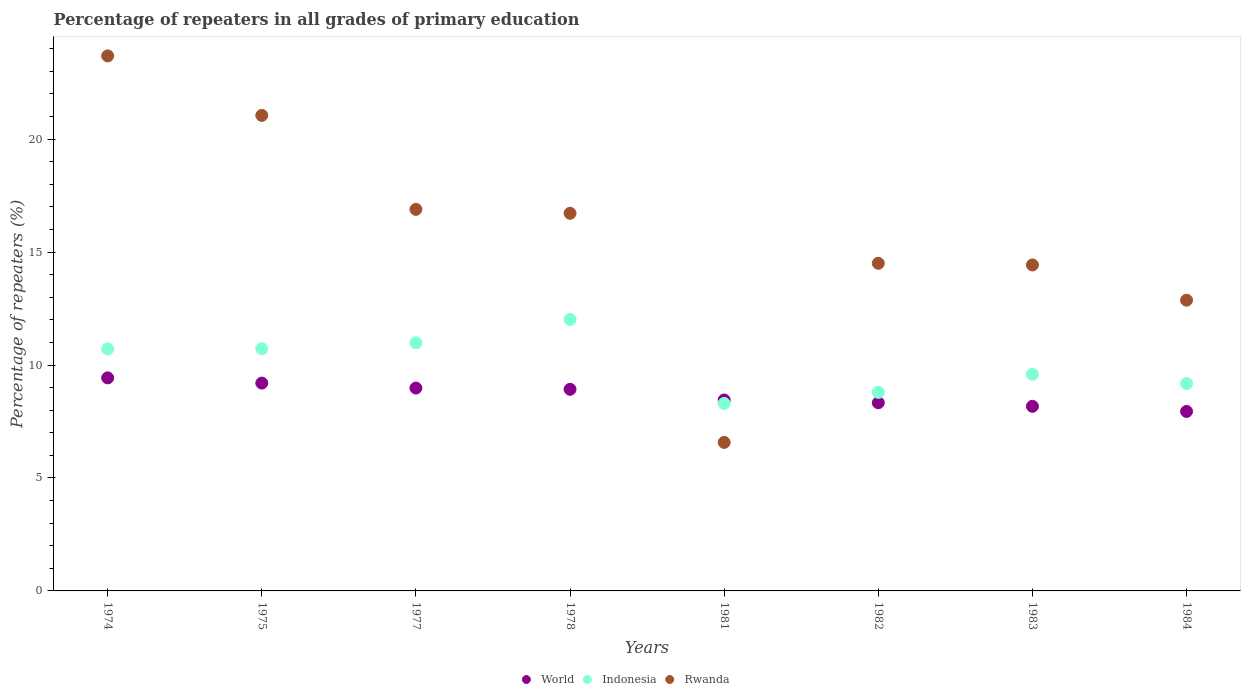What is the percentage of repeaters in Rwanda in 1978?
Your answer should be very brief. 16.72. Across all years, what is the maximum percentage of repeaters in Indonesia?
Offer a very short reply. 12.02. Across all years, what is the minimum percentage of repeaters in World?
Your answer should be very brief. 7.95. In which year was the percentage of repeaters in Indonesia maximum?
Your answer should be compact. 1978. In which year was the percentage of repeaters in World minimum?
Offer a terse response. 1984. What is the total percentage of repeaters in World in the graph?
Offer a terse response. 69.44. What is the difference between the percentage of repeaters in World in 1978 and that in 1982?
Your answer should be very brief. 0.6. What is the difference between the percentage of repeaters in Indonesia in 1983 and the percentage of repeaters in Rwanda in 1982?
Offer a very short reply. -4.91. What is the average percentage of repeaters in Indonesia per year?
Offer a terse response. 10.04. In the year 1982, what is the difference between the percentage of repeaters in Rwanda and percentage of repeaters in World?
Ensure brevity in your answer.  6.17. What is the ratio of the percentage of repeaters in World in 1982 to that in 1984?
Offer a very short reply. 1.05. Is the difference between the percentage of repeaters in Rwanda in 1981 and 1983 greater than the difference between the percentage of repeaters in World in 1981 and 1983?
Your response must be concise. No. What is the difference between the highest and the second highest percentage of repeaters in Indonesia?
Keep it short and to the point. 1.03. What is the difference between the highest and the lowest percentage of repeaters in Indonesia?
Offer a terse response. 3.72. In how many years, is the percentage of repeaters in Rwanda greater than the average percentage of repeaters in Rwanda taken over all years?
Offer a terse response. 4. Is it the case that in every year, the sum of the percentage of repeaters in Indonesia and percentage of repeaters in World  is greater than the percentage of repeaters in Rwanda?
Provide a short and direct response. No. Is the percentage of repeaters in Indonesia strictly less than the percentage of repeaters in Rwanda over the years?
Offer a terse response. No. How many years are there in the graph?
Make the answer very short. 8. What is the difference between two consecutive major ticks on the Y-axis?
Offer a very short reply. 5. Does the graph contain any zero values?
Your answer should be very brief. No. How are the legend labels stacked?
Your answer should be compact. Horizontal. What is the title of the graph?
Offer a terse response. Percentage of repeaters in all grades of primary education. Does "Mauritius" appear as one of the legend labels in the graph?
Make the answer very short. No. What is the label or title of the X-axis?
Give a very brief answer. Years. What is the label or title of the Y-axis?
Your answer should be compact. Percentage of repeaters (%). What is the Percentage of repeaters (%) of World in 1974?
Provide a succinct answer. 9.43. What is the Percentage of repeaters (%) of Indonesia in 1974?
Ensure brevity in your answer.  10.71. What is the Percentage of repeaters (%) in Rwanda in 1974?
Your answer should be very brief. 23.69. What is the Percentage of repeaters (%) of World in 1975?
Your answer should be compact. 9.2. What is the Percentage of repeaters (%) of Indonesia in 1975?
Make the answer very short. 10.72. What is the Percentage of repeaters (%) of Rwanda in 1975?
Ensure brevity in your answer.  21.05. What is the Percentage of repeaters (%) of World in 1977?
Provide a short and direct response. 8.98. What is the Percentage of repeaters (%) of Indonesia in 1977?
Provide a succinct answer. 10.98. What is the Percentage of repeaters (%) of Rwanda in 1977?
Your answer should be compact. 16.89. What is the Percentage of repeaters (%) of World in 1978?
Your response must be concise. 8.93. What is the Percentage of repeaters (%) of Indonesia in 1978?
Provide a succinct answer. 12.02. What is the Percentage of repeaters (%) of Rwanda in 1978?
Provide a succinct answer. 16.72. What is the Percentage of repeaters (%) in World in 1981?
Your answer should be compact. 8.45. What is the Percentage of repeaters (%) of Indonesia in 1981?
Offer a terse response. 8.3. What is the Percentage of repeaters (%) in Rwanda in 1981?
Offer a terse response. 6.58. What is the Percentage of repeaters (%) in World in 1982?
Provide a succinct answer. 8.33. What is the Percentage of repeaters (%) in Indonesia in 1982?
Ensure brevity in your answer.  8.79. What is the Percentage of repeaters (%) of Rwanda in 1982?
Keep it short and to the point. 14.5. What is the Percentage of repeaters (%) of World in 1983?
Provide a short and direct response. 8.17. What is the Percentage of repeaters (%) in Indonesia in 1983?
Offer a terse response. 9.59. What is the Percentage of repeaters (%) in Rwanda in 1983?
Keep it short and to the point. 14.43. What is the Percentage of repeaters (%) in World in 1984?
Make the answer very short. 7.95. What is the Percentage of repeaters (%) in Indonesia in 1984?
Offer a terse response. 9.18. What is the Percentage of repeaters (%) of Rwanda in 1984?
Offer a terse response. 12.87. Across all years, what is the maximum Percentage of repeaters (%) in World?
Your response must be concise. 9.43. Across all years, what is the maximum Percentage of repeaters (%) in Indonesia?
Ensure brevity in your answer.  12.02. Across all years, what is the maximum Percentage of repeaters (%) in Rwanda?
Keep it short and to the point. 23.69. Across all years, what is the minimum Percentage of repeaters (%) in World?
Make the answer very short. 7.95. Across all years, what is the minimum Percentage of repeaters (%) in Indonesia?
Keep it short and to the point. 8.3. Across all years, what is the minimum Percentage of repeaters (%) of Rwanda?
Keep it short and to the point. 6.58. What is the total Percentage of repeaters (%) of World in the graph?
Keep it short and to the point. 69.44. What is the total Percentage of repeaters (%) of Indonesia in the graph?
Provide a succinct answer. 80.3. What is the total Percentage of repeaters (%) of Rwanda in the graph?
Make the answer very short. 126.73. What is the difference between the Percentage of repeaters (%) in World in 1974 and that in 1975?
Ensure brevity in your answer.  0.23. What is the difference between the Percentage of repeaters (%) in Indonesia in 1974 and that in 1975?
Your response must be concise. -0.01. What is the difference between the Percentage of repeaters (%) of Rwanda in 1974 and that in 1975?
Your response must be concise. 2.63. What is the difference between the Percentage of repeaters (%) of World in 1974 and that in 1977?
Make the answer very short. 0.45. What is the difference between the Percentage of repeaters (%) of Indonesia in 1974 and that in 1977?
Ensure brevity in your answer.  -0.27. What is the difference between the Percentage of repeaters (%) of Rwanda in 1974 and that in 1977?
Give a very brief answer. 6.79. What is the difference between the Percentage of repeaters (%) of World in 1974 and that in 1978?
Your answer should be very brief. 0.51. What is the difference between the Percentage of repeaters (%) in Indonesia in 1974 and that in 1978?
Your answer should be compact. -1.3. What is the difference between the Percentage of repeaters (%) in Rwanda in 1974 and that in 1978?
Offer a terse response. 6.97. What is the difference between the Percentage of repeaters (%) of World in 1974 and that in 1981?
Your answer should be compact. 0.98. What is the difference between the Percentage of repeaters (%) of Indonesia in 1974 and that in 1981?
Make the answer very short. 2.41. What is the difference between the Percentage of repeaters (%) of Rwanda in 1974 and that in 1981?
Your response must be concise. 17.11. What is the difference between the Percentage of repeaters (%) of World in 1974 and that in 1982?
Make the answer very short. 1.1. What is the difference between the Percentage of repeaters (%) of Indonesia in 1974 and that in 1982?
Give a very brief answer. 1.92. What is the difference between the Percentage of repeaters (%) of Rwanda in 1974 and that in 1982?
Your answer should be compact. 9.18. What is the difference between the Percentage of repeaters (%) in World in 1974 and that in 1983?
Ensure brevity in your answer.  1.26. What is the difference between the Percentage of repeaters (%) in Indonesia in 1974 and that in 1983?
Keep it short and to the point. 1.12. What is the difference between the Percentage of repeaters (%) in Rwanda in 1974 and that in 1983?
Make the answer very short. 9.25. What is the difference between the Percentage of repeaters (%) of World in 1974 and that in 1984?
Provide a short and direct response. 1.49. What is the difference between the Percentage of repeaters (%) of Indonesia in 1974 and that in 1984?
Your response must be concise. 1.53. What is the difference between the Percentage of repeaters (%) of Rwanda in 1974 and that in 1984?
Your answer should be compact. 10.81. What is the difference between the Percentage of repeaters (%) in World in 1975 and that in 1977?
Your answer should be very brief. 0.22. What is the difference between the Percentage of repeaters (%) of Indonesia in 1975 and that in 1977?
Your answer should be compact. -0.26. What is the difference between the Percentage of repeaters (%) of Rwanda in 1975 and that in 1977?
Ensure brevity in your answer.  4.16. What is the difference between the Percentage of repeaters (%) of World in 1975 and that in 1978?
Your answer should be very brief. 0.28. What is the difference between the Percentage of repeaters (%) in Indonesia in 1975 and that in 1978?
Provide a succinct answer. -1.29. What is the difference between the Percentage of repeaters (%) of Rwanda in 1975 and that in 1978?
Ensure brevity in your answer.  4.33. What is the difference between the Percentage of repeaters (%) in World in 1975 and that in 1981?
Make the answer very short. 0.75. What is the difference between the Percentage of repeaters (%) in Indonesia in 1975 and that in 1981?
Keep it short and to the point. 2.42. What is the difference between the Percentage of repeaters (%) of Rwanda in 1975 and that in 1981?
Your answer should be very brief. 14.48. What is the difference between the Percentage of repeaters (%) in World in 1975 and that in 1982?
Your response must be concise. 0.87. What is the difference between the Percentage of repeaters (%) of Indonesia in 1975 and that in 1982?
Your answer should be compact. 1.93. What is the difference between the Percentage of repeaters (%) of Rwanda in 1975 and that in 1982?
Your response must be concise. 6.55. What is the difference between the Percentage of repeaters (%) in World in 1975 and that in 1983?
Provide a short and direct response. 1.03. What is the difference between the Percentage of repeaters (%) in Indonesia in 1975 and that in 1983?
Your response must be concise. 1.13. What is the difference between the Percentage of repeaters (%) in Rwanda in 1975 and that in 1983?
Offer a terse response. 6.62. What is the difference between the Percentage of repeaters (%) of World in 1975 and that in 1984?
Give a very brief answer. 1.26. What is the difference between the Percentage of repeaters (%) of Indonesia in 1975 and that in 1984?
Give a very brief answer. 1.54. What is the difference between the Percentage of repeaters (%) of Rwanda in 1975 and that in 1984?
Provide a succinct answer. 8.18. What is the difference between the Percentage of repeaters (%) in World in 1977 and that in 1978?
Your answer should be compact. 0.05. What is the difference between the Percentage of repeaters (%) in Indonesia in 1977 and that in 1978?
Ensure brevity in your answer.  -1.03. What is the difference between the Percentage of repeaters (%) of Rwanda in 1977 and that in 1978?
Provide a succinct answer. 0.17. What is the difference between the Percentage of repeaters (%) in World in 1977 and that in 1981?
Provide a short and direct response. 0.53. What is the difference between the Percentage of repeaters (%) in Indonesia in 1977 and that in 1981?
Your response must be concise. 2.68. What is the difference between the Percentage of repeaters (%) of Rwanda in 1977 and that in 1981?
Your answer should be compact. 10.32. What is the difference between the Percentage of repeaters (%) of World in 1977 and that in 1982?
Provide a succinct answer. 0.65. What is the difference between the Percentage of repeaters (%) in Indonesia in 1977 and that in 1982?
Your response must be concise. 2.19. What is the difference between the Percentage of repeaters (%) in Rwanda in 1977 and that in 1982?
Your answer should be very brief. 2.39. What is the difference between the Percentage of repeaters (%) of World in 1977 and that in 1983?
Your answer should be very brief. 0.81. What is the difference between the Percentage of repeaters (%) of Indonesia in 1977 and that in 1983?
Your answer should be very brief. 1.39. What is the difference between the Percentage of repeaters (%) of Rwanda in 1977 and that in 1983?
Make the answer very short. 2.46. What is the difference between the Percentage of repeaters (%) of World in 1977 and that in 1984?
Make the answer very short. 1.03. What is the difference between the Percentage of repeaters (%) of Indonesia in 1977 and that in 1984?
Ensure brevity in your answer.  1.8. What is the difference between the Percentage of repeaters (%) of Rwanda in 1977 and that in 1984?
Ensure brevity in your answer.  4.02. What is the difference between the Percentage of repeaters (%) in World in 1978 and that in 1981?
Offer a very short reply. 0.47. What is the difference between the Percentage of repeaters (%) in Indonesia in 1978 and that in 1981?
Offer a very short reply. 3.72. What is the difference between the Percentage of repeaters (%) of Rwanda in 1978 and that in 1981?
Your answer should be very brief. 10.14. What is the difference between the Percentage of repeaters (%) of World in 1978 and that in 1982?
Your answer should be very brief. 0.6. What is the difference between the Percentage of repeaters (%) in Indonesia in 1978 and that in 1982?
Keep it short and to the point. 3.23. What is the difference between the Percentage of repeaters (%) of Rwanda in 1978 and that in 1982?
Offer a terse response. 2.21. What is the difference between the Percentage of repeaters (%) of World in 1978 and that in 1983?
Provide a short and direct response. 0.75. What is the difference between the Percentage of repeaters (%) of Indonesia in 1978 and that in 1983?
Give a very brief answer. 2.43. What is the difference between the Percentage of repeaters (%) in Rwanda in 1978 and that in 1983?
Give a very brief answer. 2.29. What is the difference between the Percentage of repeaters (%) in World in 1978 and that in 1984?
Offer a very short reply. 0.98. What is the difference between the Percentage of repeaters (%) of Indonesia in 1978 and that in 1984?
Provide a succinct answer. 2.84. What is the difference between the Percentage of repeaters (%) of Rwanda in 1978 and that in 1984?
Provide a succinct answer. 3.85. What is the difference between the Percentage of repeaters (%) of World in 1981 and that in 1982?
Your answer should be very brief. 0.12. What is the difference between the Percentage of repeaters (%) of Indonesia in 1981 and that in 1982?
Keep it short and to the point. -0.49. What is the difference between the Percentage of repeaters (%) in Rwanda in 1981 and that in 1982?
Keep it short and to the point. -7.93. What is the difference between the Percentage of repeaters (%) of World in 1981 and that in 1983?
Keep it short and to the point. 0.28. What is the difference between the Percentage of repeaters (%) of Indonesia in 1981 and that in 1983?
Provide a succinct answer. -1.29. What is the difference between the Percentage of repeaters (%) of Rwanda in 1981 and that in 1983?
Give a very brief answer. -7.86. What is the difference between the Percentage of repeaters (%) in World in 1981 and that in 1984?
Provide a short and direct response. 0.51. What is the difference between the Percentage of repeaters (%) of Indonesia in 1981 and that in 1984?
Your answer should be compact. -0.88. What is the difference between the Percentage of repeaters (%) in Rwanda in 1981 and that in 1984?
Provide a short and direct response. -6.3. What is the difference between the Percentage of repeaters (%) of World in 1982 and that in 1983?
Offer a terse response. 0.16. What is the difference between the Percentage of repeaters (%) in Indonesia in 1982 and that in 1983?
Keep it short and to the point. -0.8. What is the difference between the Percentage of repeaters (%) of Rwanda in 1982 and that in 1983?
Ensure brevity in your answer.  0.07. What is the difference between the Percentage of repeaters (%) in World in 1982 and that in 1984?
Your response must be concise. 0.38. What is the difference between the Percentage of repeaters (%) of Indonesia in 1982 and that in 1984?
Offer a very short reply. -0.39. What is the difference between the Percentage of repeaters (%) in Rwanda in 1982 and that in 1984?
Give a very brief answer. 1.63. What is the difference between the Percentage of repeaters (%) of World in 1983 and that in 1984?
Keep it short and to the point. 0.23. What is the difference between the Percentage of repeaters (%) of Indonesia in 1983 and that in 1984?
Give a very brief answer. 0.41. What is the difference between the Percentage of repeaters (%) in Rwanda in 1983 and that in 1984?
Offer a terse response. 1.56. What is the difference between the Percentage of repeaters (%) in World in 1974 and the Percentage of repeaters (%) in Indonesia in 1975?
Provide a short and direct response. -1.29. What is the difference between the Percentage of repeaters (%) of World in 1974 and the Percentage of repeaters (%) of Rwanda in 1975?
Make the answer very short. -11.62. What is the difference between the Percentage of repeaters (%) of Indonesia in 1974 and the Percentage of repeaters (%) of Rwanda in 1975?
Give a very brief answer. -10.34. What is the difference between the Percentage of repeaters (%) of World in 1974 and the Percentage of repeaters (%) of Indonesia in 1977?
Make the answer very short. -1.55. What is the difference between the Percentage of repeaters (%) in World in 1974 and the Percentage of repeaters (%) in Rwanda in 1977?
Your answer should be very brief. -7.46. What is the difference between the Percentage of repeaters (%) in Indonesia in 1974 and the Percentage of repeaters (%) in Rwanda in 1977?
Provide a short and direct response. -6.18. What is the difference between the Percentage of repeaters (%) in World in 1974 and the Percentage of repeaters (%) in Indonesia in 1978?
Provide a succinct answer. -2.59. What is the difference between the Percentage of repeaters (%) of World in 1974 and the Percentage of repeaters (%) of Rwanda in 1978?
Ensure brevity in your answer.  -7.29. What is the difference between the Percentage of repeaters (%) of Indonesia in 1974 and the Percentage of repeaters (%) of Rwanda in 1978?
Provide a succinct answer. -6.01. What is the difference between the Percentage of repeaters (%) of World in 1974 and the Percentage of repeaters (%) of Indonesia in 1981?
Offer a terse response. 1.13. What is the difference between the Percentage of repeaters (%) of World in 1974 and the Percentage of repeaters (%) of Rwanda in 1981?
Make the answer very short. 2.86. What is the difference between the Percentage of repeaters (%) of Indonesia in 1974 and the Percentage of repeaters (%) of Rwanda in 1981?
Your response must be concise. 4.14. What is the difference between the Percentage of repeaters (%) of World in 1974 and the Percentage of repeaters (%) of Indonesia in 1982?
Offer a very short reply. 0.64. What is the difference between the Percentage of repeaters (%) of World in 1974 and the Percentage of repeaters (%) of Rwanda in 1982?
Your answer should be very brief. -5.07. What is the difference between the Percentage of repeaters (%) in Indonesia in 1974 and the Percentage of repeaters (%) in Rwanda in 1982?
Make the answer very short. -3.79. What is the difference between the Percentage of repeaters (%) of World in 1974 and the Percentage of repeaters (%) of Indonesia in 1983?
Your response must be concise. -0.16. What is the difference between the Percentage of repeaters (%) in World in 1974 and the Percentage of repeaters (%) in Rwanda in 1983?
Provide a short and direct response. -5. What is the difference between the Percentage of repeaters (%) of Indonesia in 1974 and the Percentage of repeaters (%) of Rwanda in 1983?
Offer a terse response. -3.72. What is the difference between the Percentage of repeaters (%) in World in 1974 and the Percentage of repeaters (%) in Indonesia in 1984?
Give a very brief answer. 0.25. What is the difference between the Percentage of repeaters (%) of World in 1974 and the Percentage of repeaters (%) of Rwanda in 1984?
Your answer should be very brief. -3.44. What is the difference between the Percentage of repeaters (%) of Indonesia in 1974 and the Percentage of repeaters (%) of Rwanda in 1984?
Your answer should be compact. -2.16. What is the difference between the Percentage of repeaters (%) of World in 1975 and the Percentage of repeaters (%) of Indonesia in 1977?
Ensure brevity in your answer.  -1.78. What is the difference between the Percentage of repeaters (%) in World in 1975 and the Percentage of repeaters (%) in Rwanda in 1977?
Provide a succinct answer. -7.69. What is the difference between the Percentage of repeaters (%) in Indonesia in 1975 and the Percentage of repeaters (%) in Rwanda in 1977?
Your answer should be very brief. -6.17. What is the difference between the Percentage of repeaters (%) in World in 1975 and the Percentage of repeaters (%) in Indonesia in 1978?
Make the answer very short. -2.82. What is the difference between the Percentage of repeaters (%) in World in 1975 and the Percentage of repeaters (%) in Rwanda in 1978?
Your answer should be compact. -7.52. What is the difference between the Percentage of repeaters (%) of Indonesia in 1975 and the Percentage of repeaters (%) of Rwanda in 1978?
Offer a terse response. -6. What is the difference between the Percentage of repeaters (%) in World in 1975 and the Percentage of repeaters (%) in Indonesia in 1981?
Your answer should be very brief. 0.9. What is the difference between the Percentage of repeaters (%) of World in 1975 and the Percentage of repeaters (%) of Rwanda in 1981?
Provide a succinct answer. 2.63. What is the difference between the Percentage of repeaters (%) of Indonesia in 1975 and the Percentage of repeaters (%) of Rwanda in 1981?
Your answer should be compact. 4.15. What is the difference between the Percentage of repeaters (%) in World in 1975 and the Percentage of repeaters (%) in Indonesia in 1982?
Provide a succinct answer. 0.41. What is the difference between the Percentage of repeaters (%) in World in 1975 and the Percentage of repeaters (%) in Rwanda in 1982?
Your answer should be compact. -5.3. What is the difference between the Percentage of repeaters (%) of Indonesia in 1975 and the Percentage of repeaters (%) of Rwanda in 1982?
Provide a short and direct response. -3.78. What is the difference between the Percentage of repeaters (%) of World in 1975 and the Percentage of repeaters (%) of Indonesia in 1983?
Your response must be concise. -0.39. What is the difference between the Percentage of repeaters (%) of World in 1975 and the Percentage of repeaters (%) of Rwanda in 1983?
Offer a terse response. -5.23. What is the difference between the Percentage of repeaters (%) in Indonesia in 1975 and the Percentage of repeaters (%) in Rwanda in 1983?
Give a very brief answer. -3.71. What is the difference between the Percentage of repeaters (%) of World in 1975 and the Percentage of repeaters (%) of Indonesia in 1984?
Your answer should be compact. 0.02. What is the difference between the Percentage of repeaters (%) in World in 1975 and the Percentage of repeaters (%) in Rwanda in 1984?
Ensure brevity in your answer.  -3.67. What is the difference between the Percentage of repeaters (%) in Indonesia in 1975 and the Percentage of repeaters (%) in Rwanda in 1984?
Your response must be concise. -2.15. What is the difference between the Percentage of repeaters (%) of World in 1977 and the Percentage of repeaters (%) of Indonesia in 1978?
Give a very brief answer. -3.04. What is the difference between the Percentage of repeaters (%) in World in 1977 and the Percentage of repeaters (%) in Rwanda in 1978?
Offer a terse response. -7.74. What is the difference between the Percentage of repeaters (%) of Indonesia in 1977 and the Percentage of repeaters (%) of Rwanda in 1978?
Your response must be concise. -5.74. What is the difference between the Percentage of repeaters (%) of World in 1977 and the Percentage of repeaters (%) of Indonesia in 1981?
Offer a terse response. 0.68. What is the difference between the Percentage of repeaters (%) in World in 1977 and the Percentage of repeaters (%) in Rwanda in 1981?
Provide a short and direct response. 2.41. What is the difference between the Percentage of repeaters (%) in Indonesia in 1977 and the Percentage of repeaters (%) in Rwanda in 1981?
Your answer should be compact. 4.41. What is the difference between the Percentage of repeaters (%) in World in 1977 and the Percentage of repeaters (%) in Indonesia in 1982?
Your answer should be very brief. 0.19. What is the difference between the Percentage of repeaters (%) of World in 1977 and the Percentage of repeaters (%) of Rwanda in 1982?
Your response must be concise. -5.52. What is the difference between the Percentage of repeaters (%) in Indonesia in 1977 and the Percentage of repeaters (%) in Rwanda in 1982?
Make the answer very short. -3.52. What is the difference between the Percentage of repeaters (%) in World in 1977 and the Percentage of repeaters (%) in Indonesia in 1983?
Ensure brevity in your answer.  -0.61. What is the difference between the Percentage of repeaters (%) of World in 1977 and the Percentage of repeaters (%) of Rwanda in 1983?
Offer a terse response. -5.45. What is the difference between the Percentage of repeaters (%) of Indonesia in 1977 and the Percentage of repeaters (%) of Rwanda in 1983?
Your response must be concise. -3.45. What is the difference between the Percentage of repeaters (%) of World in 1977 and the Percentage of repeaters (%) of Indonesia in 1984?
Your response must be concise. -0.2. What is the difference between the Percentage of repeaters (%) of World in 1977 and the Percentage of repeaters (%) of Rwanda in 1984?
Your answer should be very brief. -3.89. What is the difference between the Percentage of repeaters (%) in Indonesia in 1977 and the Percentage of repeaters (%) in Rwanda in 1984?
Give a very brief answer. -1.89. What is the difference between the Percentage of repeaters (%) in World in 1978 and the Percentage of repeaters (%) in Indonesia in 1981?
Your response must be concise. 0.62. What is the difference between the Percentage of repeaters (%) of World in 1978 and the Percentage of repeaters (%) of Rwanda in 1981?
Keep it short and to the point. 2.35. What is the difference between the Percentage of repeaters (%) of Indonesia in 1978 and the Percentage of repeaters (%) of Rwanda in 1981?
Provide a succinct answer. 5.44. What is the difference between the Percentage of repeaters (%) in World in 1978 and the Percentage of repeaters (%) in Indonesia in 1982?
Your answer should be very brief. 0.14. What is the difference between the Percentage of repeaters (%) in World in 1978 and the Percentage of repeaters (%) in Rwanda in 1982?
Offer a very short reply. -5.58. What is the difference between the Percentage of repeaters (%) in Indonesia in 1978 and the Percentage of repeaters (%) in Rwanda in 1982?
Offer a terse response. -2.49. What is the difference between the Percentage of repeaters (%) in World in 1978 and the Percentage of repeaters (%) in Indonesia in 1983?
Keep it short and to the point. -0.66. What is the difference between the Percentage of repeaters (%) of World in 1978 and the Percentage of repeaters (%) of Rwanda in 1983?
Provide a short and direct response. -5.51. What is the difference between the Percentage of repeaters (%) in Indonesia in 1978 and the Percentage of repeaters (%) in Rwanda in 1983?
Your response must be concise. -2.41. What is the difference between the Percentage of repeaters (%) of World in 1978 and the Percentage of repeaters (%) of Indonesia in 1984?
Keep it short and to the point. -0.25. What is the difference between the Percentage of repeaters (%) in World in 1978 and the Percentage of repeaters (%) in Rwanda in 1984?
Ensure brevity in your answer.  -3.95. What is the difference between the Percentage of repeaters (%) of Indonesia in 1978 and the Percentage of repeaters (%) of Rwanda in 1984?
Provide a succinct answer. -0.85. What is the difference between the Percentage of repeaters (%) of World in 1981 and the Percentage of repeaters (%) of Indonesia in 1982?
Provide a succinct answer. -0.34. What is the difference between the Percentage of repeaters (%) in World in 1981 and the Percentage of repeaters (%) in Rwanda in 1982?
Provide a short and direct response. -6.05. What is the difference between the Percentage of repeaters (%) in Indonesia in 1981 and the Percentage of repeaters (%) in Rwanda in 1982?
Provide a succinct answer. -6.2. What is the difference between the Percentage of repeaters (%) in World in 1981 and the Percentage of repeaters (%) in Indonesia in 1983?
Make the answer very short. -1.14. What is the difference between the Percentage of repeaters (%) in World in 1981 and the Percentage of repeaters (%) in Rwanda in 1983?
Provide a succinct answer. -5.98. What is the difference between the Percentage of repeaters (%) of Indonesia in 1981 and the Percentage of repeaters (%) of Rwanda in 1983?
Give a very brief answer. -6.13. What is the difference between the Percentage of repeaters (%) in World in 1981 and the Percentage of repeaters (%) in Indonesia in 1984?
Ensure brevity in your answer.  -0.73. What is the difference between the Percentage of repeaters (%) in World in 1981 and the Percentage of repeaters (%) in Rwanda in 1984?
Ensure brevity in your answer.  -4.42. What is the difference between the Percentage of repeaters (%) of Indonesia in 1981 and the Percentage of repeaters (%) of Rwanda in 1984?
Offer a very short reply. -4.57. What is the difference between the Percentage of repeaters (%) of World in 1982 and the Percentage of repeaters (%) of Indonesia in 1983?
Your answer should be compact. -1.26. What is the difference between the Percentage of repeaters (%) of World in 1982 and the Percentage of repeaters (%) of Rwanda in 1983?
Keep it short and to the point. -6.1. What is the difference between the Percentage of repeaters (%) of Indonesia in 1982 and the Percentage of repeaters (%) of Rwanda in 1983?
Offer a terse response. -5.64. What is the difference between the Percentage of repeaters (%) of World in 1982 and the Percentage of repeaters (%) of Indonesia in 1984?
Provide a short and direct response. -0.85. What is the difference between the Percentage of repeaters (%) of World in 1982 and the Percentage of repeaters (%) of Rwanda in 1984?
Give a very brief answer. -4.54. What is the difference between the Percentage of repeaters (%) in Indonesia in 1982 and the Percentage of repeaters (%) in Rwanda in 1984?
Ensure brevity in your answer.  -4.08. What is the difference between the Percentage of repeaters (%) of World in 1983 and the Percentage of repeaters (%) of Indonesia in 1984?
Your answer should be compact. -1.01. What is the difference between the Percentage of repeaters (%) of World in 1983 and the Percentage of repeaters (%) of Rwanda in 1984?
Offer a terse response. -4.7. What is the difference between the Percentage of repeaters (%) in Indonesia in 1983 and the Percentage of repeaters (%) in Rwanda in 1984?
Your answer should be very brief. -3.28. What is the average Percentage of repeaters (%) of World per year?
Your answer should be very brief. 8.68. What is the average Percentage of repeaters (%) of Indonesia per year?
Give a very brief answer. 10.04. What is the average Percentage of repeaters (%) of Rwanda per year?
Your response must be concise. 15.84. In the year 1974, what is the difference between the Percentage of repeaters (%) of World and Percentage of repeaters (%) of Indonesia?
Keep it short and to the point. -1.28. In the year 1974, what is the difference between the Percentage of repeaters (%) of World and Percentage of repeaters (%) of Rwanda?
Your answer should be compact. -14.25. In the year 1974, what is the difference between the Percentage of repeaters (%) in Indonesia and Percentage of repeaters (%) in Rwanda?
Your answer should be very brief. -12.97. In the year 1975, what is the difference between the Percentage of repeaters (%) of World and Percentage of repeaters (%) of Indonesia?
Your answer should be compact. -1.52. In the year 1975, what is the difference between the Percentage of repeaters (%) in World and Percentage of repeaters (%) in Rwanda?
Offer a terse response. -11.85. In the year 1975, what is the difference between the Percentage of repeaters (%) of Indonesia and Percentage of repeaters (%) of Rwanda?
Ensure brevity in your answer.  -10.33. In the year 1977, what is the difference between the Percentage of repeaters (%) in World and Percentage of repeaters (%) in Indonesia?
Give a very brief answer. -2. In the year 1977, what is the difference between the Percentage of repeaters (%) in World and Percentage of repeaters (%) in Rwanda?
Provide a short and direct response. -7.91. In the year 1977, what is the difference between the Percentage of repeaters (%) of Indonesia and Percentage of repeaters (%) of Rwanda?
Provide a succinct answer. -5.91. In the year 1978, what is the difference between the Percentage of repeaters (%) of World and Percentage of repeaters (%) of Indonesia?
Your answer should be compact. -3.09. In the year 1978, what is the difference between the Percentage of repeaters (%) in World and Percentage of repeaters (%) in Rwanda?
Your response must be concise. -7.79. In the year 1978, what is the difference between the Percentage of repeaters (%) of Indonesia and Percentage of repeaters (%) of Rwanda?
Provide a short and direct response. -4.7. In the year 1981, what is the difference between the Percentage of repeaters (%) in World and Percentage of repeaters (%) in Indonesia?
Offer a very short reply. 0.15. In the year 1981, what is the difference between the Percentage of repeaters (%) in World and Percentage of repeaters (%) in Rwanda?
Offer a very short reply. 1.88. In the year 1981, what is the difference between the Percentage of repeaters (%) in Indonesia and Percentage of repeaters (%) in Rwanda?
Offer a terse response. 1.73. In the year 1982, what is the difference between the Percentage of repeaters (%) of World and Percentage of repeaters (%) of Indonesia?
Give a very brief answer. -0.46. In the year 1982, what is the difference between the Percentage of repeaters (%) in World and Percentage of repeaters (%) in Rwanda?
Your response must be concise. -6.17. In the year 1982, what is the difference between the Percentage of repeaters (%) of Indonesia and Percentage of repeaters (%) of Rwanda?
Provide a succinct answer. -5.71. In the year 1983, what is the difference between the Percentage of repeaters (%) in World and Percentage of repeaters (%) in Indonesia?
Ensure brevity in your answer.  -1.42. In the year 1983, what is the difference between the Percentage of repeaters (%) in World and Percentage of repeaters (%) in Rwanda?
Provide a succinct answer. -6.26. In the year 1983, what is the difference between the Percentage of repeaters (%) of Indonesia and Percentage of repeaters (%) of Rwanda?
Your answer should be compact. -4.84. In the year 1984, what is the difference between the Percentage of repeaters (%) of World and Percentage of repeaters (%) of Indonesia?
Give a very brief answer. -1.23. In the year 1984, what is the difference between the Percentage of repeaters (%) in World and Percentage of repeaters (%) in Rwanda?
Ensure brevity in your answer.  -4.93. In the year 1984, what is the difference between the Percentage of repeaters (%) in Indonesia and Percentage of repeaters (%) in Rwanda?
Offer a very short reply. -3.69. What is the ratio of the Percentage of repeaters (%) in World in 1974 to that in 1975?
Provide a succinct answer. 1.02. What is the ratio of the Percentage of repeaters (%) of Rwanda in 1974 to that in 1975?
Provide a short and direct response. 1.13. What is the ratio of the Percentage of repeaters (%) in World in 1974 to that in 1977?
Offer a terse response. 1.05. What is the ratio of the Percentage of repeaters (%) in Indonesia in 1974 to that in 1977?
Provide a short and direct response. 0.98. What is the ratio of the Percentage of repeaters (%) in Rwanda in 1974 to that in 1977?
Provide a succinct answer. 1.4. What is the ratio of the Percentage of repeaters (%) of World in 1974 to that in 1978?
Provide a short and direct response. 1.06. What is the ratio of the Percentage of repeaters (%) in Indonesia in 1974 to that in 1978?
Keep it short and to the point. 0.89. What is the ratio of the Percentage of repeaters (%) in Rwanda in 1974 to that in 1978?
Offer a very short reply. 1.42. What is the ratio of the Percentage of repeaters (%) in World in 1974 to that in 1981?
Offer a terse response. 1.12. What is the ratio of the Percentage of repeaters (%) in Indonesia in 1974 to that in 1981?
Give a very brief answer. 1.29. What is the ratio of the Percentage of repeaters (%) in Rwanda in 1974 to that in 1981?
Give a very brief answer. 3.6. What is the ratio of the Percentage of repeaters (%) in World in 1974 to that in 1982?
Make the answer very short. 1.13. What is the ratio of the Percentage of repeaters (%) of Indonesia in 1974 to that in 1982?
Your answer should be very brief. 1.22. What is the ratio of the Percentage of repeaters (%) of Rwanda in 1974 to that in 1982?
Offer a very short reply. 1.63. What is the ratio of the Percentage of repeaters (%) in World in 1974 to that in 1983?
Offer a terse response. 1.15. What is the ratio of the Percentage of repeaters (%) in Indonesia in 1974 to that in 1983?
Your response must be concise. 1.12. What is the ratio of the Percentage of repeaters (%) of Rwanda in 1974 to that in 1983?
Your answer should be very brief. 1.64. What is the ratio of the Percentage of repeaters (%) of World in 1974 to that in 1984?
Offer a terse response. 1.19. What is the ratio of the Percentage of repeaters (%) of Indonesia in 1974 to that in 1984?
Keep it short and to the point. 1.17. What is the ratio of the Percentage of repeaters (%) in Rwanda in 1974 to that in 1984?
Ensure brevity in your answer.  1.84. What is the ratio of the Percentage of repeaters (%) of World in 1975 to that in 1977?
Provide a short and direct response. 1.02. What is the ratio of the Percentage of repeaters (%) of Indonesia in 1975 to that in 1977?
Give a very brief answer. 0.98. What is the ratio of the Percentage of repeaters (%) of Rwanda in 1975 to that in 1977?
Ensure brevity in your answer.  1.25. What is the ratio of the Percentage of repeaters (%) of World in 1975 to that in 1978?
Your answer should be compact. 1.03. What is the ratio of the Percentage of repeaters (%) of Indonesia in 1975 to that in 1978?
Provide a short and direct response. 0.89. What is the ratio of the Percentage of repeaters (%) of Rwanda in 1975 to that in 1978?
Ensure brevity in your answer.  1.26. What is the ratio of the Percentage of repeaters (%) in World in 1975 to that in 1981?
Provide a short and direct response. 1.09. What is the ratio of the Percentage of repeaters (%) in Indonesia in 1975 to that in 1981?
Offer a terse response. 1.29. What is the ratio of the Percentage of repeaters (%) of Rwanda in 1975 to that in 1981?
Your answer should be very brief. 3.2. What is the ratio of the Percentage of repeaters (%) in World in 1975 to that in 1982?
Provide a short and direct response. 1.1. What is the ratio of the Percentage of repeaters (%) in Indonesia in 1975 to that in 1982?
Offer a very short reply. 1.22. What is the ratio of the Percentage of repeaters (%) of Rwanda in 1975 to that in 1982?
Your answer should be very brief. 1.45. What is the ratio of the Percentage of repeaters (%) of World in 1975 to that in 1983?
Your response must be concise. 1.13. What is the ratio of the Percentage of repeaters (%) in Indonesia in 1975 to that in 1983?
Your answer should be very brief. 1.12. What is the ratio of the Percentage of repeaters (%) of Rwanda in 1975 to that in 1983?
Provide a short and direct response. 1.46. What is the ratio of the Percentage of repeaters (%) of World in 1975 to that in 1984?
Make the answer very short. 1.16. What is the ratio of the Percentage of repeaters (%) in Indonesia in 1975 to that in 1984?
Give a very brief answer. 1.17. What is the ratio of the Percentage of repeaters (%) of Rwanda in 1975 to that in 1984?
Ensure brevity in your answer.  1.64. What is the ratio of the Percentage of repeaters (%) in World in 1977 to that in 1978?
Make the answer very short. 1.01. What is the ratio of the Percentage of repeaters (%) in Indonesia in 1977 to that in 1978?
Offer a very short reply. 0.91. What is the ratio of the Percentage of repeaters (%) in Rwanda in 1977 to that in 1978?
Give a very brief answer. 1.01. What is the ratio of the Percentage of repeaters (%) of World in 1977 to that in 1981?
Provide a succinct answer. 1.06. What is the ratio of the Percentage of repeaters (%) in Indonesia in 1977 to that in 1981?
Give a very brief answer. 1.32. What is the ratio of the Percentage of repeaters (%) in Rwanda in 1977 to that in 1981?
Provide a succinct answer. 2.57. What is the ratio of the Percentage of repeaters (%) in World in 1977 to that in 1982?
Your answer should be compact. 1.08. What is the ratio of the Percentage of repeaters (%) in Indonesia in 1977 to that in 1982?
Make the answer very short. 1.25. What is the ratio of the Percentage of repeaters (%) of Rwanda in 1977 to that in 1982?
Offer a terse response. 1.16. What is the ratio of the Percentage of repeaters (%) of World in 1977 to that in 1983?
Keep it short and to the point. 1.1. What is the ratio of the Percentage of repeaters (%) in Indonesia in 1977 to that in 1983?
Ensure brevity in your answer.  1.15. What is the ratio of the Percentage of repeaters (%) of Rwanda in 1977 to that in 1983?
Keep it short and to the point. 1.17. What is the ratio of the Percentage of repeaters (%) in World in 1977 to that in 1984?
Give a very brief answer. 1.13. What is the ratio of the Percentage of repeaters (%) of Indonesia in 1977 to that in 1984?
Your answer should be compact. 1.2. What is the ratio of the Percentage of repeaters (%) of Rwanda in 1977 to that in 1984?
Your response must be concise. 1.31. What is the ratio of the Percentage of repeaters (%) of World in 1978 to that in 1981?
Give a very brief answer. 1.06. What is the ratio of the Percentage of repeaters (%) in Indonesia in 1978 to that in 1981?
Your answer should be compact. 1.45. What is the ratio of the Percentage of repeaters (%) of Rwanda in 1978 to that in 1981?
Provide a succinct answer. 2.54. What is the ratio of the Percentage of repeaters (%) of World in 1978 to that in 1982?
Ensure brevity in your answer.  1.07. What is the ratio of the Percentage of repeaters (%) of Indonesia in 1978 to that in 1982?
Your response must be concise. 1.37. What is the ratio of the Percentage of repeaters (%) in Rwanda in 1978 to that in 1982?
Make the answer very short. 1.15. What is the ratio of the Percentage of repeaters (%) in World in 1978 to that in 1983?
Make the answer very short. 1.09. What is the ratio of the Percentage of repeaters (%) in Indonesia in 1978 to that in 1983?
Provide a short and direct response. 1.25. What is the ratio of the Percentage of repeaters (%) of Rwanda in 1978 to that in 1983?
Keep it short and to the point. 1.16. What is the ratio of the Percentage of repeaters (%) of World in 1978 to that in 1984?
Provide a short and direct response. 1.12. What is the ratio of the Percentage of repeaters (%) of Indonesia in 1978 to that in 1984?
Make the answer very short. 1.31. What is the ratio of the Percentage of repeaters (%) in Rwanda in 1978 to that in 1984?
Give a very brief answer. 1.3. What is the ratio of the Percentage of repeaters (%) in World in 1981 to that in 1982?
Offer a very short reply. 1.01. What is the ratio of the Percentage of repeaters (%) of Rwanda in 1981 to that in 1982?
Offer a very short reply. 0.45. What is the ratio of the Percentage of repeaters (%) of World in 1981 to that in 1983?
Make the answer very short. 1.03. What is the ratio of the Percentage of repeaters (%) of Indonesia in 1981 to that in 1983?
Offer a terse response. 0.87. What is the ratio of the Percentage of repeaters (%) of Rwanda in 1981 to that in 1983?
Keep it short and to the point. 0.46. What is the ratio of the Percentage of repeaters (%) in World in 1981 to that in 1984?
Your answer should be very brief. 1.06. What is the ratio of the Percentage of repeaters (%) of Indonesia in 1981 to that in 1984?
Ensure brevity in your answer.  0.9. What is the ratio of the Percentage of repeaters (%) of Rwanda in 1981 to that in 1984?
Ensure brevity in your answer.  0.51. What is the ratio of the Percentage of repeaters (%) of World in 1982 to that in 1983?
Give a very brief answer. 1.02. What is the ratio of the Percentage of repeaters (%) of Indonesia in 1982 to that in 1983?
Keep it short and to the point. 0.92. What is the ratio of the Percentage of repeaters (%) in Rwanda in 1982 to that in 1983?
Your answer should be very brief. 1. What is the ratio of the Percentage of repeaters (%) in World in 1982 to that in 1984?
Give a very brief answer. 1.05. What is the ratio of the Percentage of repeaters (%) of Indonesia in 1982 to that in 1984?
Keep it short and to the point. 0.96. What is the ratio of the Percentage of repeaters (%) in Rwanda in 1982 to that in 1984?
Keep it short and to the point. 1.13. What is the ratio of the Percentage of repeaters (%) in World in 1983 to that in 1984?
Your answer should be very brief. 1.03. What is the ratio of the Percentage of repeaters (%) in Indonesia in 1983 to that in 1984?
Provide a short and direct response. 1.04. What is the ratio of the Percentage of repeaters (%) of Rwanda in 1983 to that in 1984?
Keep it short and to the point. 1.12. What is the difference between the highest and the second highest Percentage of repeaters (%) of World?
Give a very brief answer. 0.23. What is the difference between the highest and the second highest Percentage of repeaters (%) of Indonesia?
Your answer should be very brief. 1.03. What is the difference between the highest and the second highest Percentage of repeaters (%) of Rwanda?
Offer a very short reply. 2.63. What is the difference between the highest and the lowest Percentage of repeaters (%) of World?
Give a very brief answer. 1.49. What is the difference between the highest and the lowest Percentage of repeaters (%) of Indonesia?
Your answer should be compact. 3.72. What is the difference between the highest and the lowest Percentage of repeaters (%) of Rwanda?
Your answer should be compact. 17.11. 